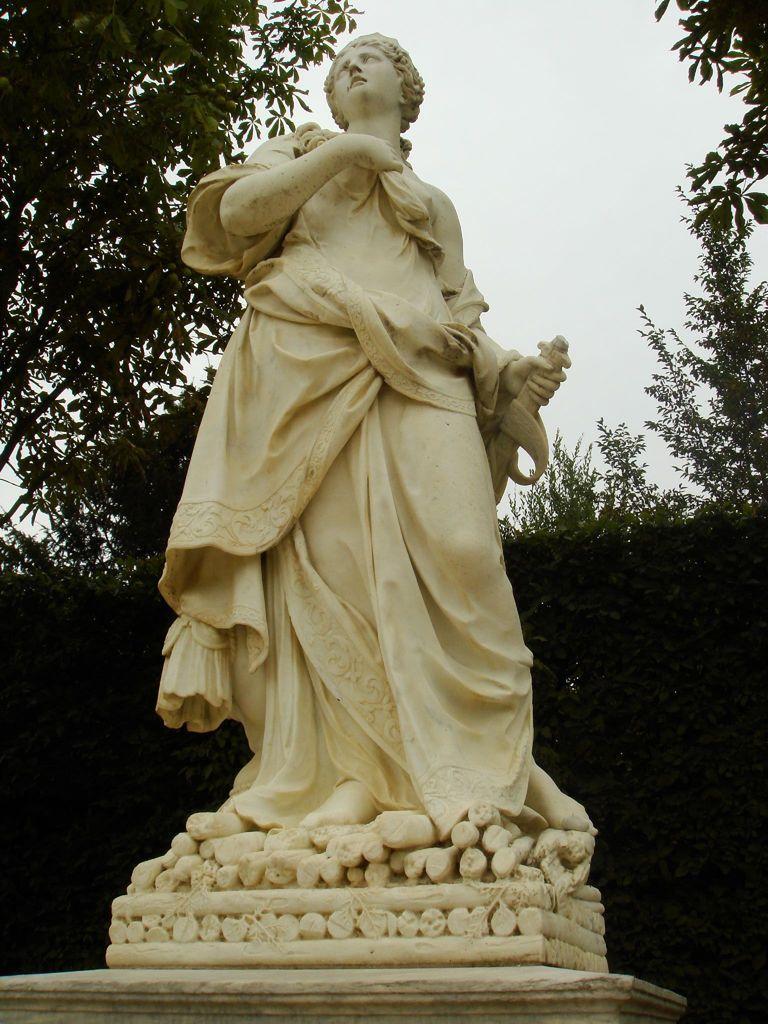Please provide a concise description of this image. In this picture, we see the stone carved statue of the woman holding the sword. There are trees in the background. At the top, we see the sky. 